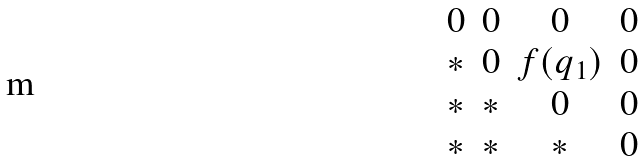Convert formula to latex. <formula><loc_0><loc_0><loc_500><loc_500>\begin{matrix} 0 & 0 & 0 & 0 \\ * & 0 & f ( q _ { 1 } ) & 0 \\ * & * & 0 & 0 \\ * & * & * & 0 \end{matrix}</formula> 